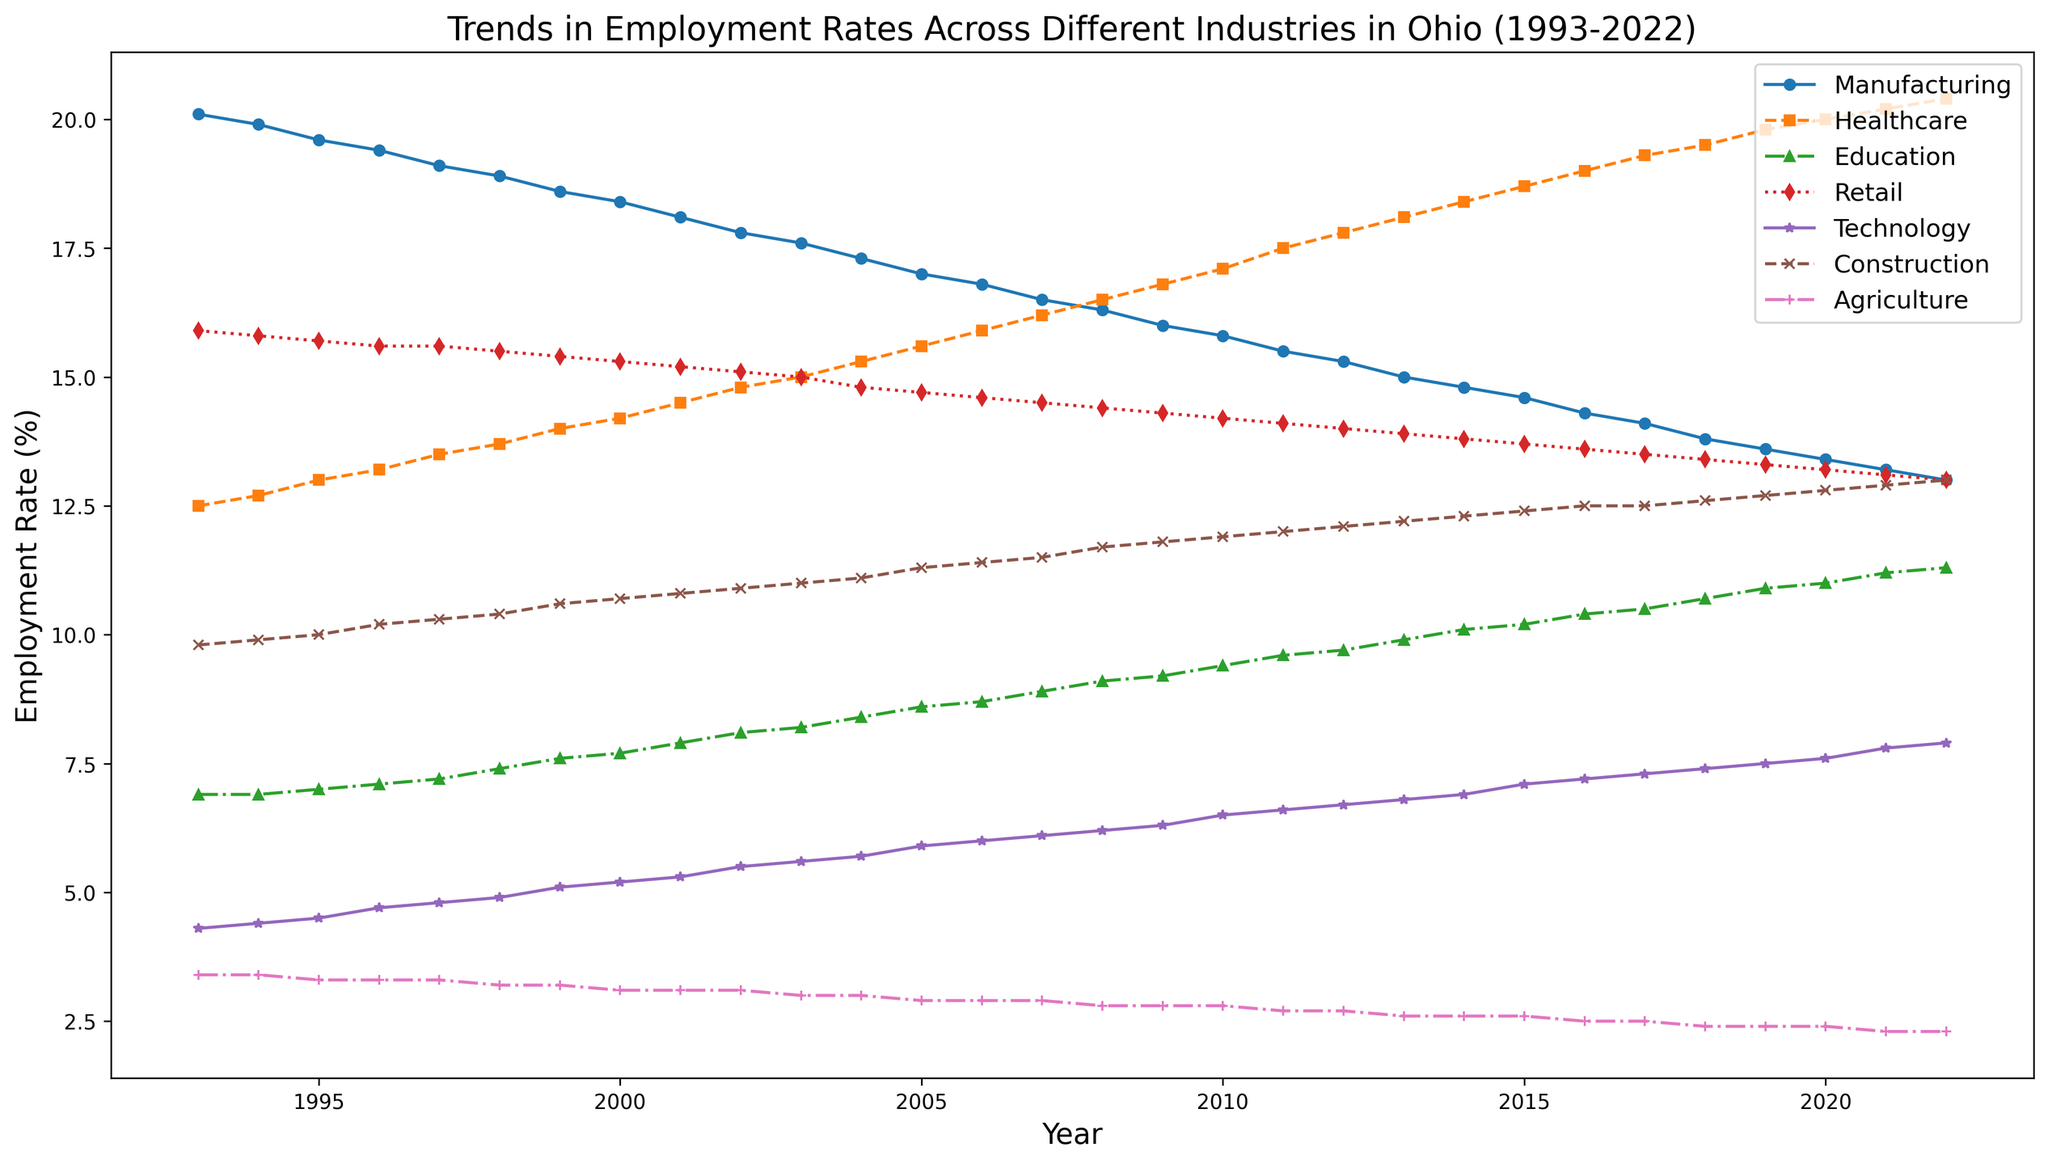Which industry had the highest employment rate in 2022? Look for the highest point in the graph for the year 2022 and identify the industry's name in the legend.
Answer: Healthcare Which two industries crossed paths around the year 2008? Locate the two lines that intersect around 2008; this means their employment rates were equal at that year.
Answer: Technology and Construction What is the difference in employment rate between Healthcare and Manufacturing in the year 2000? Find the values of Healthcare and Manufacturing in the year 2000 and subtract the Manufacturing rate from the Healthcare rate (Healthcare - Manufacturing).
Answer: 14.2 - 18.4 = -4.2 Which industry experienced the most significant increase in employment rate from 1993 to 2022? Look at the starting and ending rates for each industry and calculate their increases. The largest difference indicates the most significant increase.
Answer: Healthcare What is the average employment rate of the Agriculture industry over the 30 years? Sum the employment rates of Agriculture for each year from 1993 to 2022 and then divide by the number of years (30).
Answer: (Sum of all Agriculture rates from 1993 to 2022) / 30 In which year did Manufacturing and Agriculture have the same employment rate? Identify the year where the endpoints of the Manufacturing and Agriculture lines intersect or are very close to each other.
Answer: No year matches exactly, but they are closest around 2022 (13.0 for Manufacturing and 2.3 for Agriculture) How did the employment rate of Technology change from 1993 to 2022? Compare the values of Technology in 1993 and 2022 to see how it increased or decreased over the time period.
Answer: 2022 - 1993 = 7.9 - 4.3 = 3.6 increase Which year saw Construction peak in employment rate, and what was the value? Identify the highest point on the Construction line and check the corresponding year and value.
Answer: 2022, with a value of 13.0 What is the combined employment rate of Education and Retail in the year 2015? Add the employment rates of Education and Retail for the year 2015 together.
Answer: 10.2 (Education) + 13.7 (Retail) = 23.9 Between which two adjacent years did Retail see the most substantial drop in employment rate? Calculate the difference in rates for each pair of adjacent years for Retail and identify which pair has the largest drop (negative difference).
Answer: 2011 to 2012 (14.1 - 14.0 = 0.1, so no substantial drop observed) 